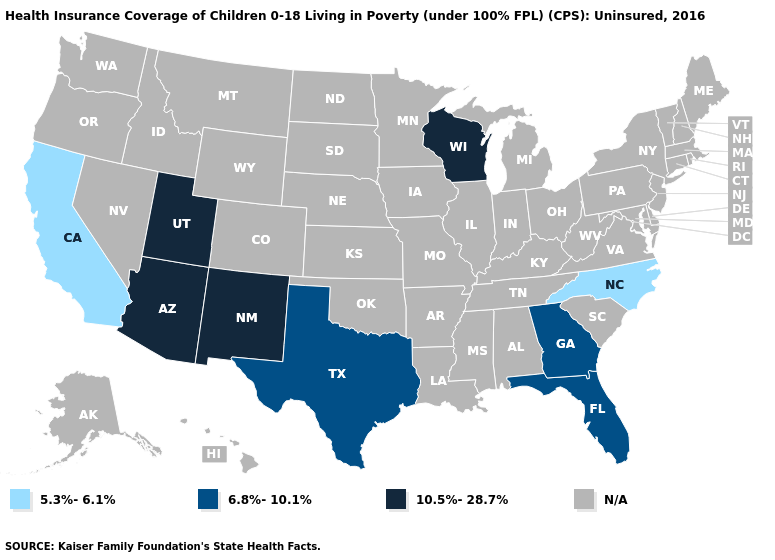Which states hav the highest value in the West?
Write a very short answer. Arizona, New Mexico, Utah. Does the first symbol in the legend represent the smallest category?
Answer briefly. Yes. What is the value of Georgia?
Quick response, please. 6.8%-10.1%. What is the value of New Jersey?
Concise answer only. N/A. Does North Carolina have the lowest value in the USA?
Write a very short answer. Yes. Which states have the highest value in the USA?
Keep it brief. Arizona, New Mexico, Utah, Wisconsin. Among the states that border Virginia , which have the highest value?
Write a very short answer. North Carolina. What is the value of New Mexico?
Concise answer only. 10.5%-28.7%. What is the value of Illinois?
Give a very brief answer. N/A. What is the value of Iowa?
Concise answer only. N/A. What is the lowest value in the USA?
Short answer required. 5.3%-6.1%. What is the value of Iowa?
Concise answer only. N/A. What is the lowest value in states that border Oregon?
Write a very short answer. 5.3%-6.1%. 